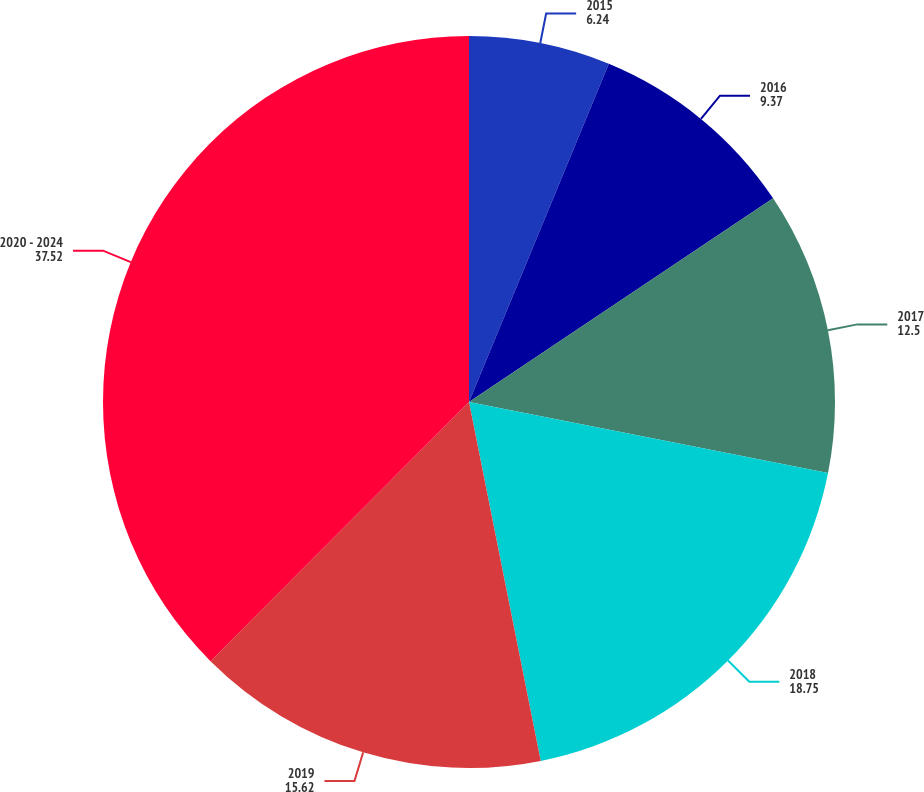Convert chart. <chart><loc_0><loc_0><loc_500><loc_500><pie_chart><fcel>2015<fcel>2016<fcel>2017<fcel>2018<fcel>2019<fcel>2020 - 2024<nl><fcel>6.24%<fcel>9.37%<fcel>12.5%<fcel>18.75%<fcel>15.62%<fcel>37.52%<nl></chart> 